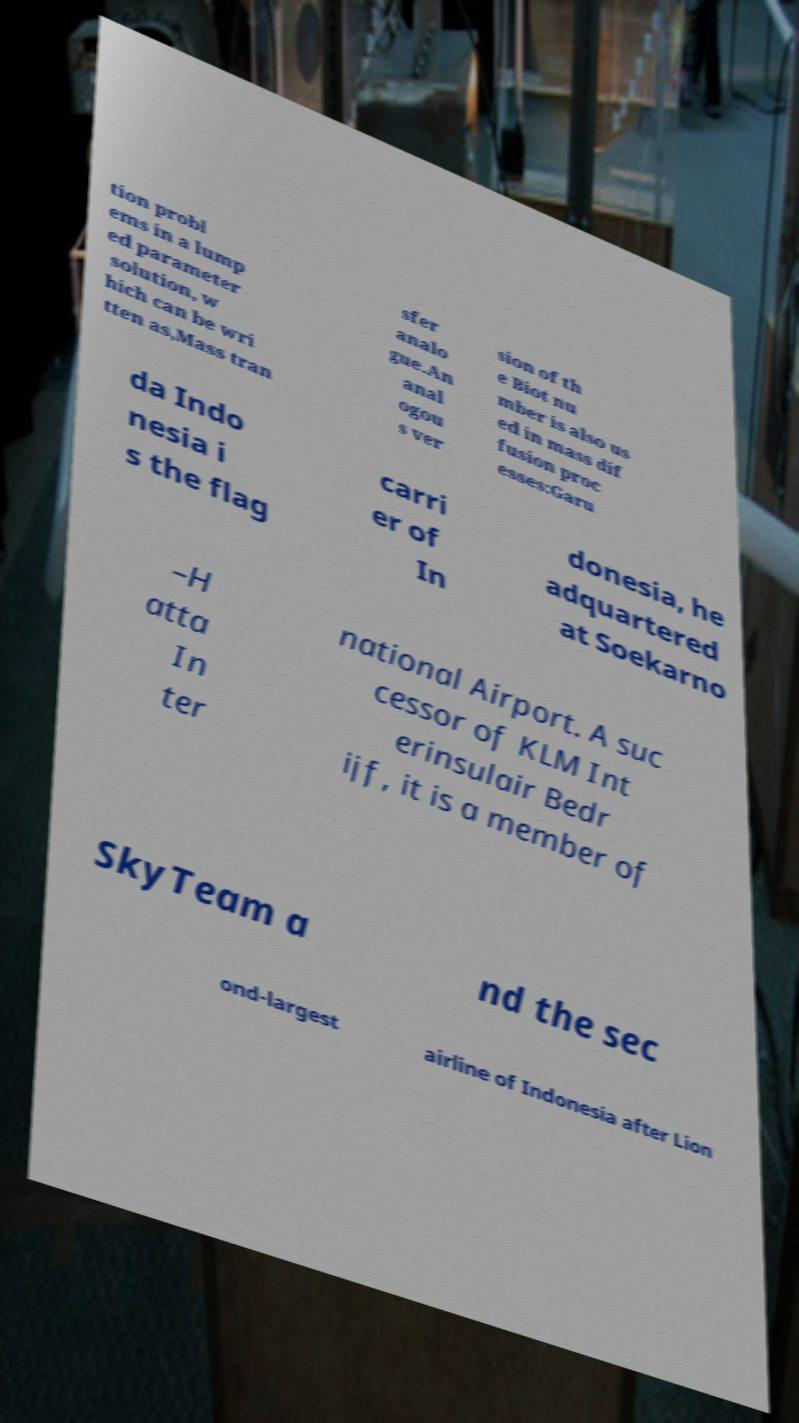Could you assist in decoding the text presented in this image and type it out clearly? tion probl ems in a lump ed parameter solution, w hich can be wri tten as,Mass tran sfer analo gue.An anal ogou s ver sion of th e Biot nu mber is also us ed in mass dif fusion proc esses:Garu da Indo nesia i s the flag carri er of In donesia, he adquartered at Soekarno –H atta In ter national Airport. A suc cessor of KLM Int erinsulair Bedr ijf, it is a member of SkyTeam a nd the sec ond-largest airline of Indonesia after Lion 